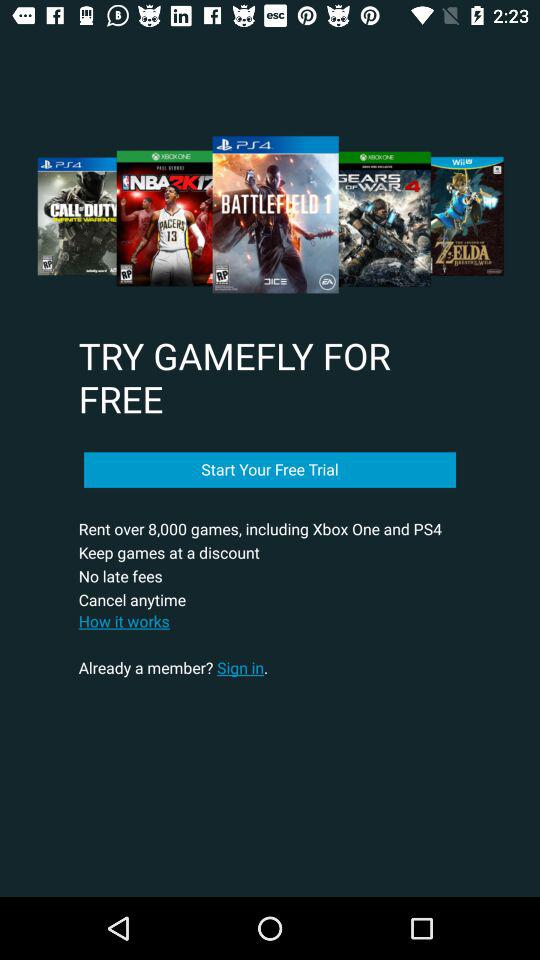Are there any late fees applicable? There are no late fees applicable. 